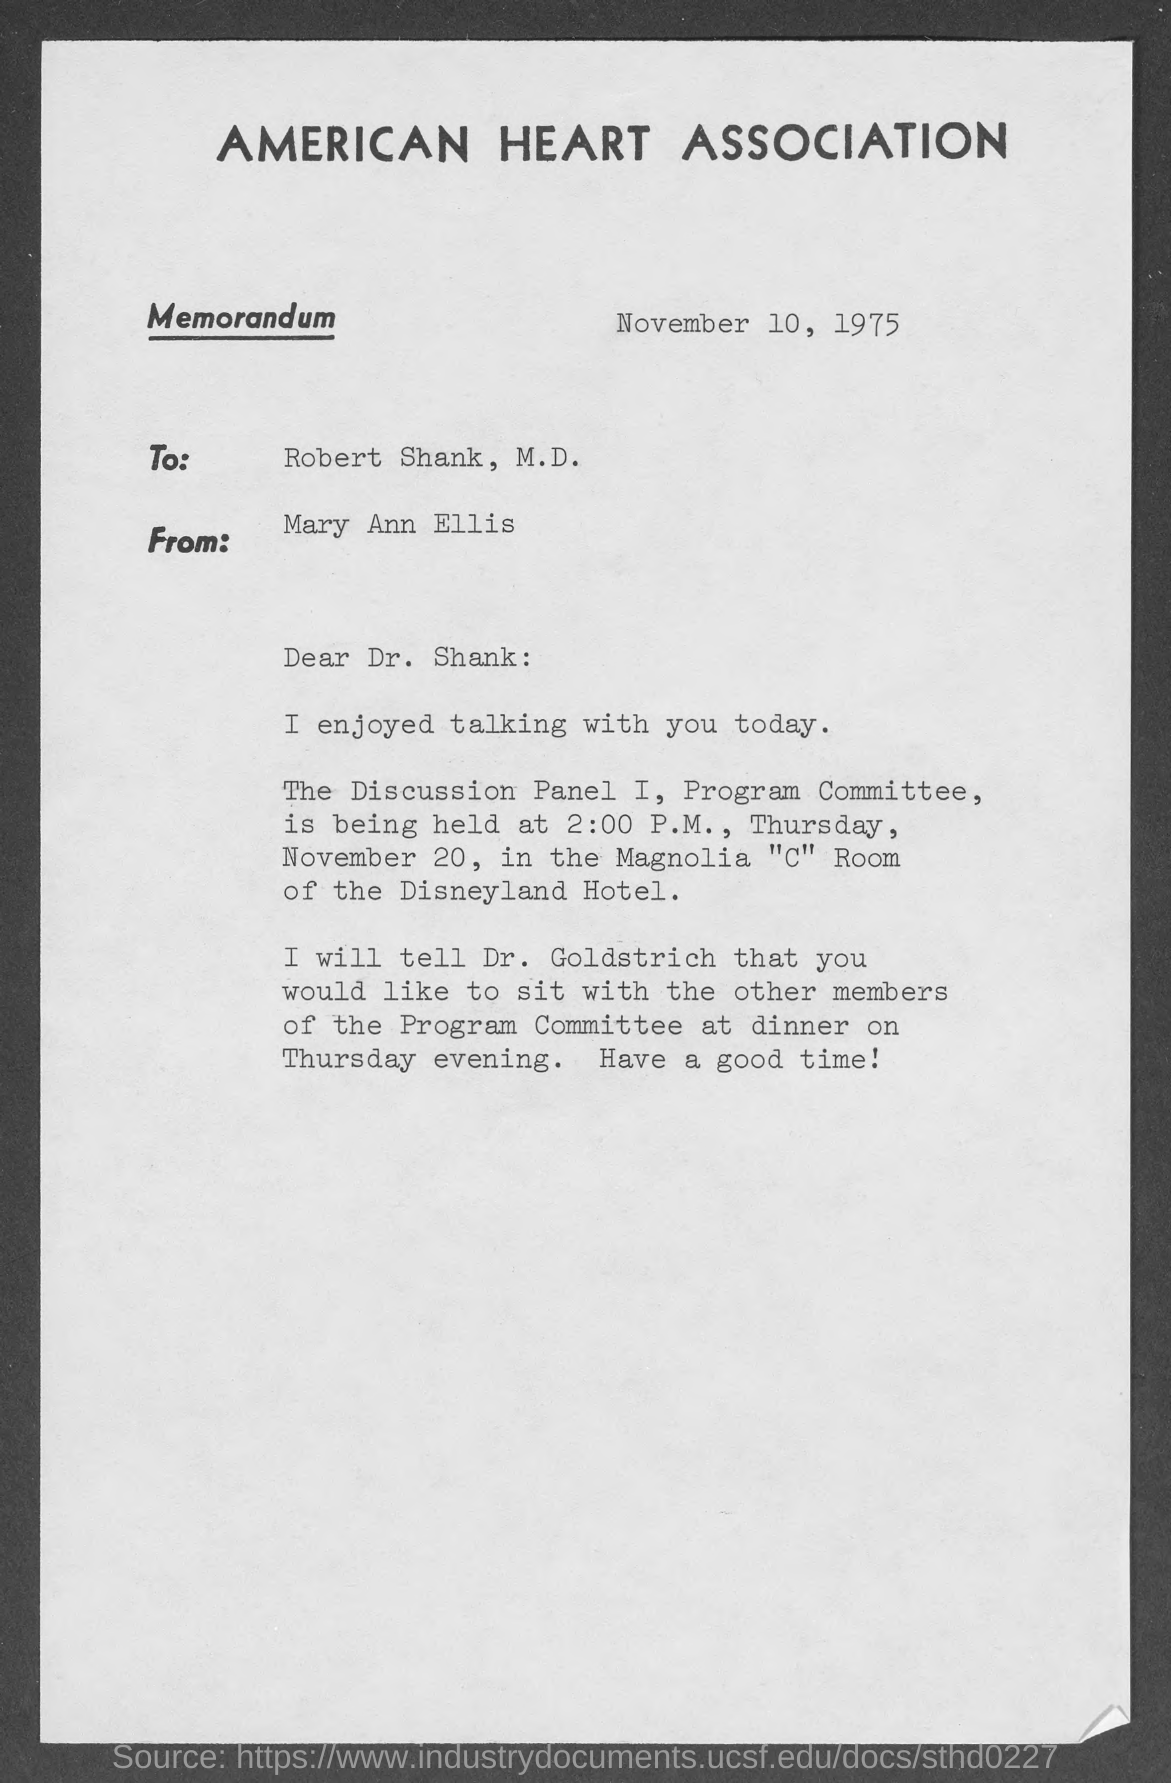Give some essential details in this illustration. At 2:00 PM, the Program Committee would begin. It is appropriate to inform Dr. Goldstrich of the dinner plan and discussion that will take place with other members of the committee. The date of issue of the memorandum was November 10, 1975. The memorandum is addressed to Robert Shank, M.D. The month of November is mentioned on the page. 